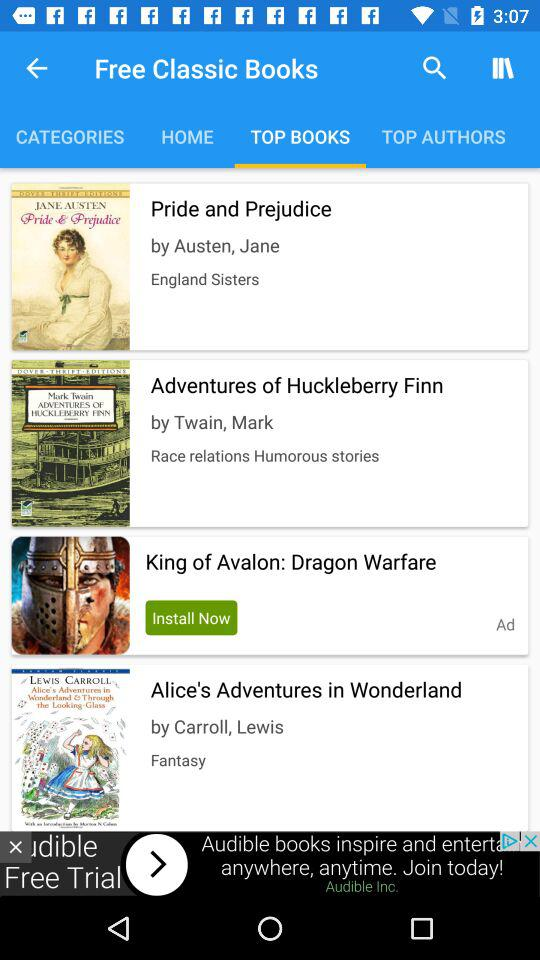What type of book is written by "Carroll, Lewis"? The type of book is "Fantasy". 